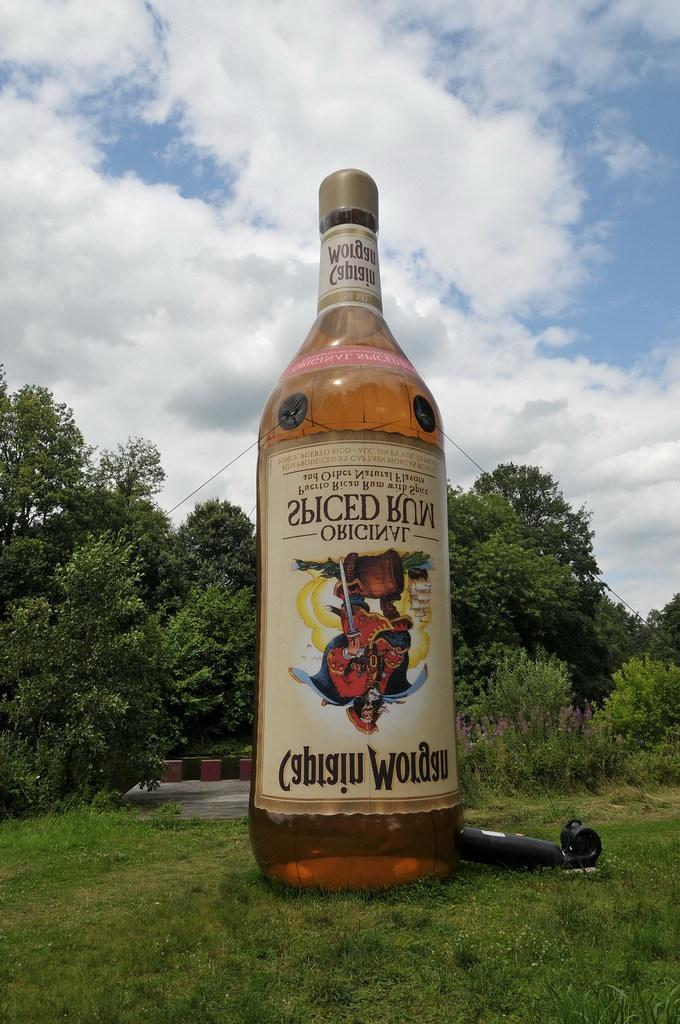Provide a one-sentence caption for the provided image. A huge blow-up bottle of Captain Morgan beer is shown on the grass. 